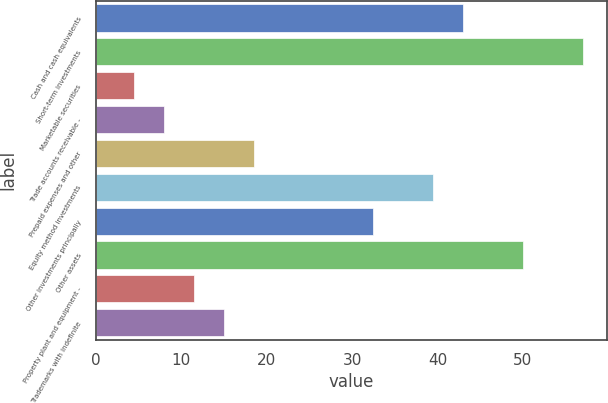<chart> <loc_0><loc_0><loc_500><loc_500><bar_chart><fcel>Cash and cash equivalents<fcel>Short-term investments<fcel>Marketable securities<fcel>Trade accounts receivable -<fcel>Prepaid expenses and other<fcel>Equity method investments<fcel>Other investments principally<fcel>Other assets<fcel>Property plant and equipment -<fcel>Trademarks with indefinite<nl><fcel>43<fcel>57<fcel>4.5<fcel>8<fcel>18.5<fcel>39.5<fcel>32.5<fcel>50<fcel>11.5<fcel>15<nl></chart> 